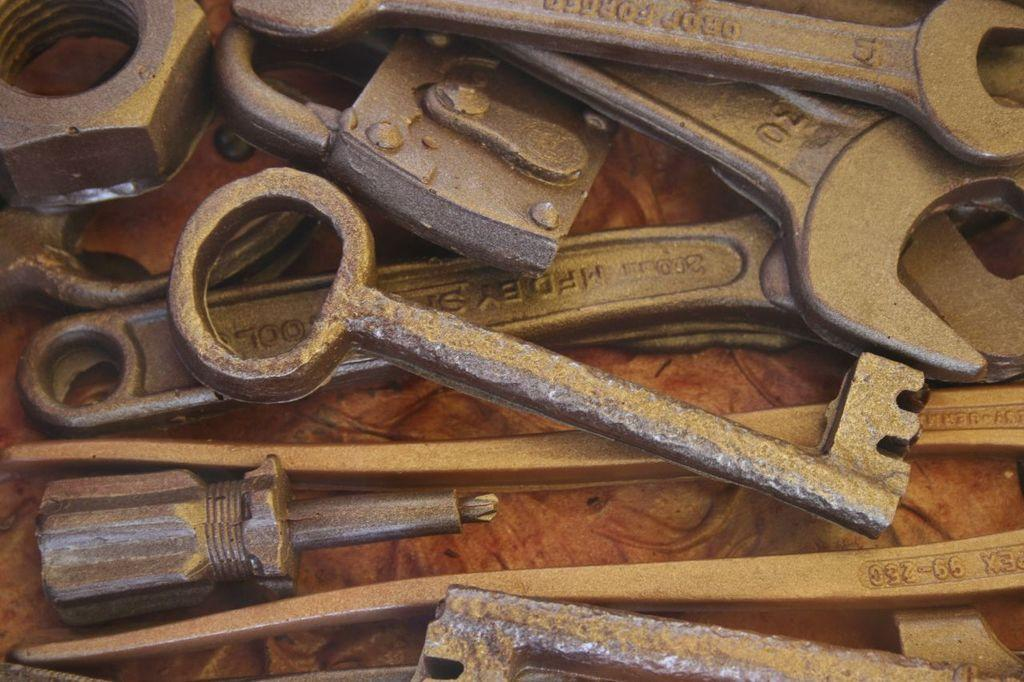What type of object can be seen in the image? There is a key, wrenches, a lock, a screwdriver, and a nut in the image. What are these objects typically used for? These objects are typically used for locking and unlocking, tightening and loosening, and fastening. Where are these objects placed in the image? All these objects are placed on a surface. What type of wood can be seen in the image? There is no wood present in the image. Are there any trousers visible in the image? There are no trousers present in the image. 